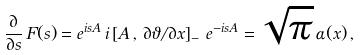Convert formula to latex. <formula><loc_0><loc_0><loc_500><loc_500>\frac { \partial } { \partial s } \, F ( s ) = e ^ { i s A } \, i \left [ A \, , \, \partial \vartheta / \partial x \right ] _ { - } \, e ^ { - i s A } = \sqrt { \pi } \, \alpha ( x ) \, ,</formula> 